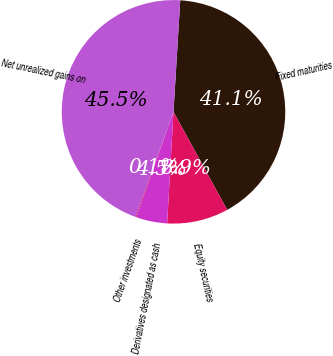Convert chart to OTSL. <chart><loc_0><loc_0><loc_500><loc_500><pie_chart><fcel>Fixed maturities<fcel>Equity securities<fcel>Derivatives designated as cash<fcel>Other investments<fcel>Net unrealized gains on<nl><fcel>41.07%<fcel>8.88%<fcel>4.49%<fcel>0.11%<fcel>45.46%<nl></chart> 